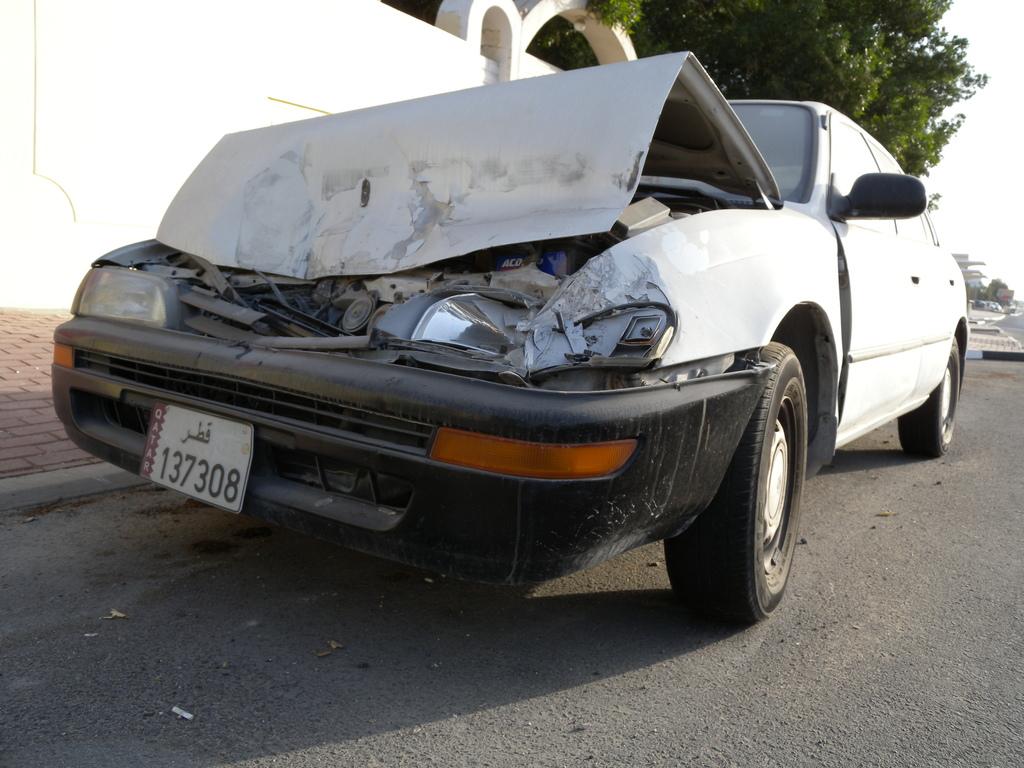What is the licence number?
Your answer should be compact. 137308. 